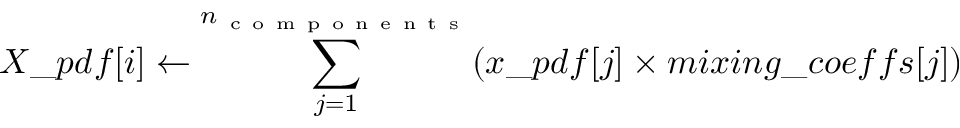<formula> <loc_0><loc_0><loc_500><loc_500>X \_ p d f [ i ] \leftarrow \sum _ { j = 1 } ^ { n _ { c o m p o n e n t s } } ( x \_ p d f [ j ] \times m i x i n g \_ c o e f f s [ j ] )</formula> 